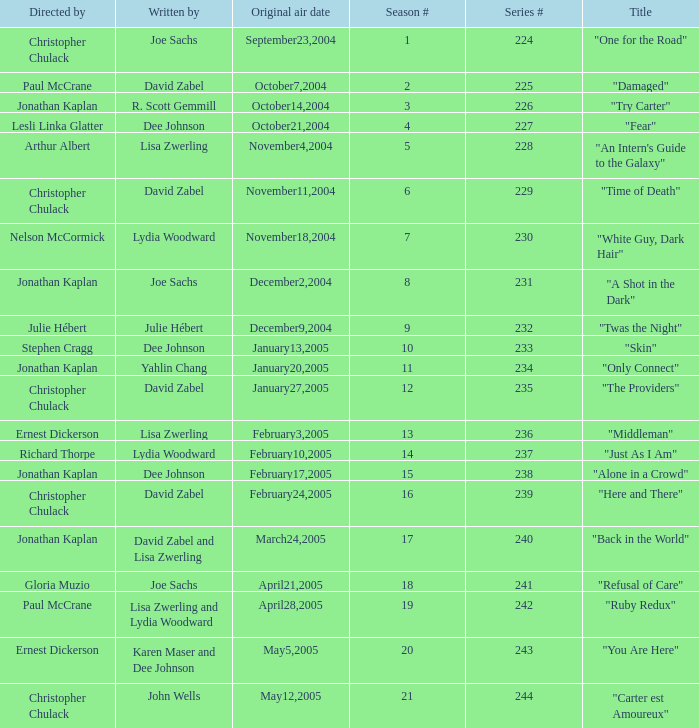Name the title that was written by r. scott gemmill "Try Carter". 